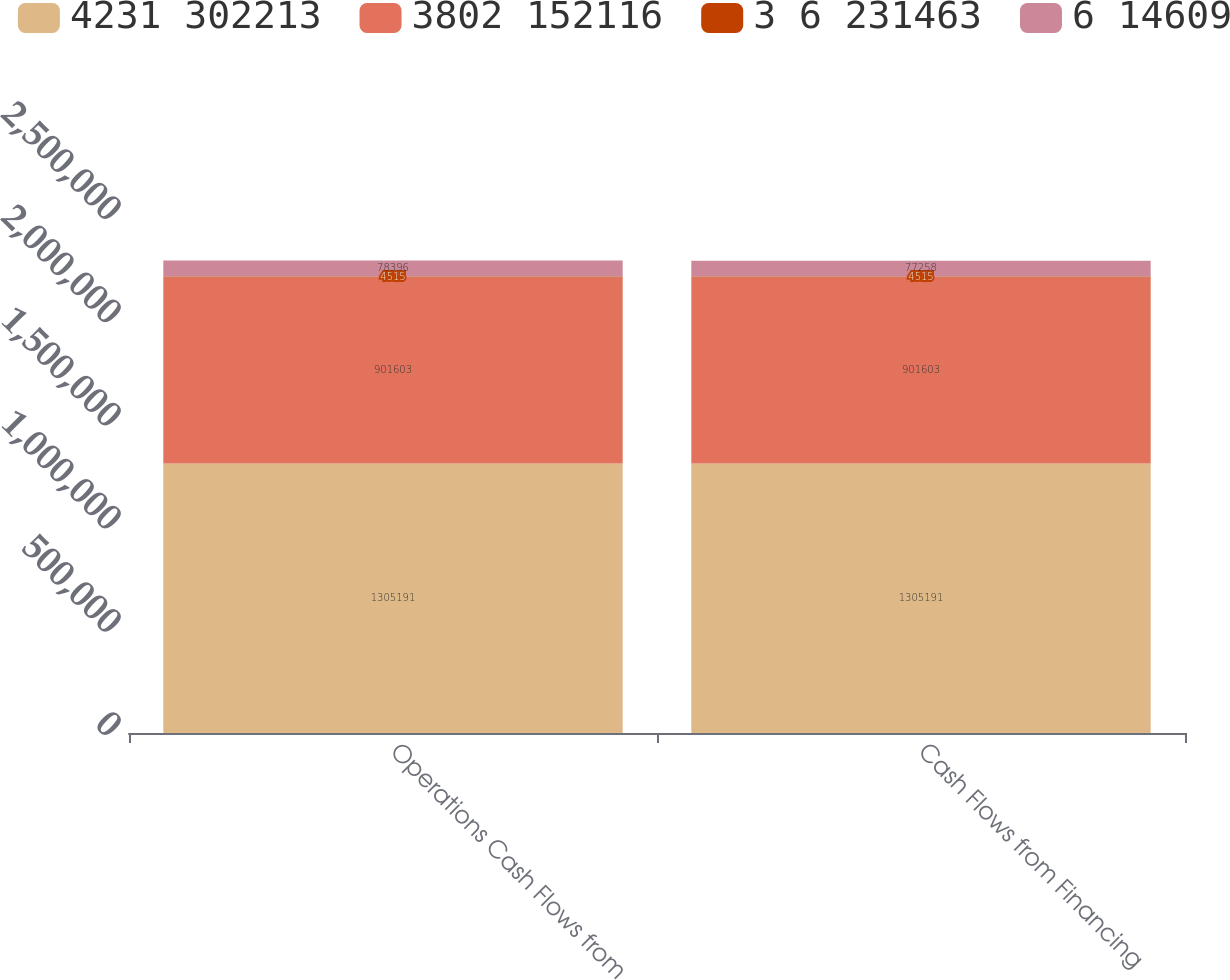<chart> <loc_0><loc_0><loc_500><loc_500><stacked_bar_chart><ecel><fcel>Operations Cash Flows from<fcel>Cash Flows from Financing<nl><fcel>4231 302213<fcel>1.30519e+06<fcel>1.30519e+06<nl><fcel>3802 152116<fcel>901603<fcel>901603<nl><fcel>3 6 231463<fcel>4515<fcel>4515<nl><fcel>6 14609<fcel>78396<fcel>77258<nl></chart> 